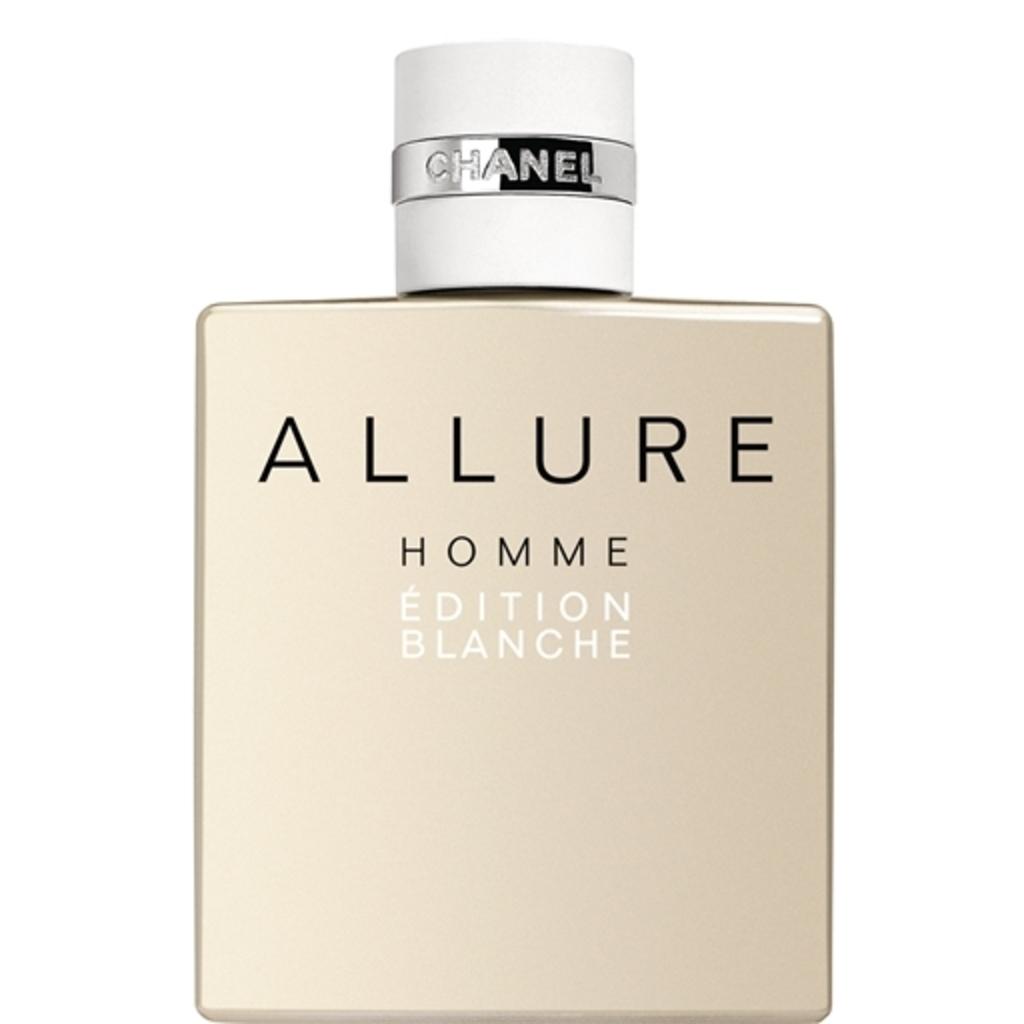Who makes this perfume?
Your answer should be very brief. Chanel. 